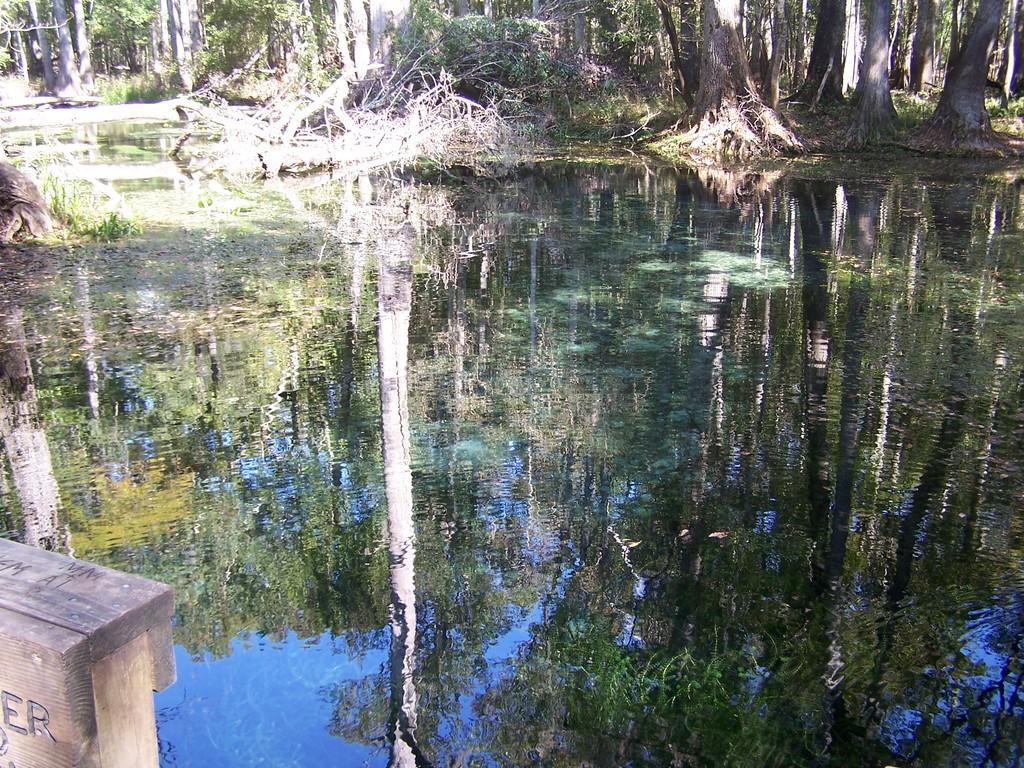Please provide a concise description of this image. In this image in the front there is water. In the background there are trees and on the bottom left there is an object which is brown in colour and there is some text written on the object 